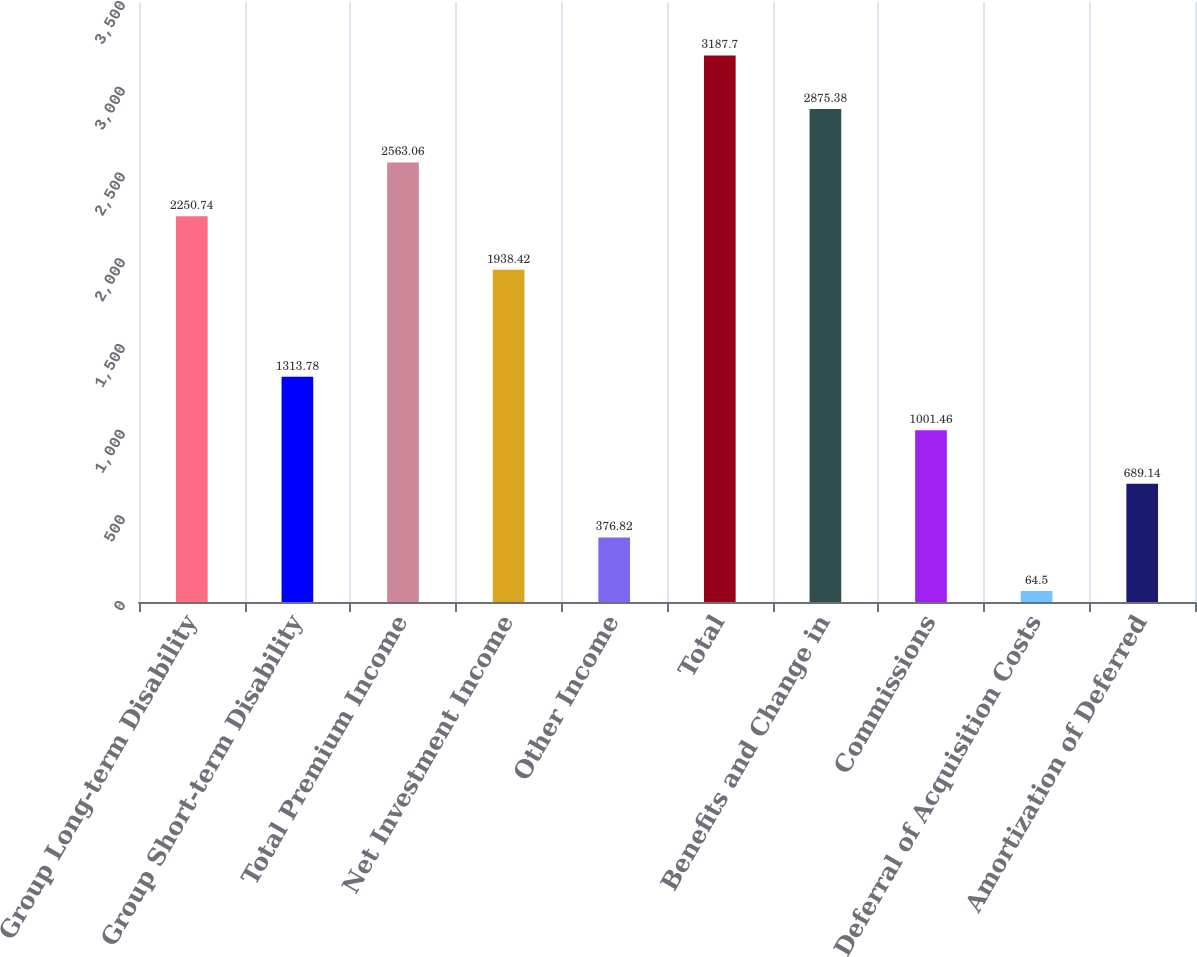Convert chart to OTSL. <chart><loc_0><loc_0><loc_500><loc_500><bar_chart><fcel>Group Long-term Disability<fcel>Group Short-term Disability<fcel>Total Premium Income<fcel>Net Investment Income<fcel>Other Income<fcel>Total<fcel>Benefits and Change in<fcel>Commissions<fcel>Deferral of Acquisition Costs<fcel>Amortization of Deferred<nl><fcel>2250.74<fcel>1313.78<fcel>2563.06<fcel>1938.42<fcel>376.82<fcel>3187.7<fcel>2875.38<fcel>1001.46<fcel>64.5<fcel>689.14<nl></chart> 